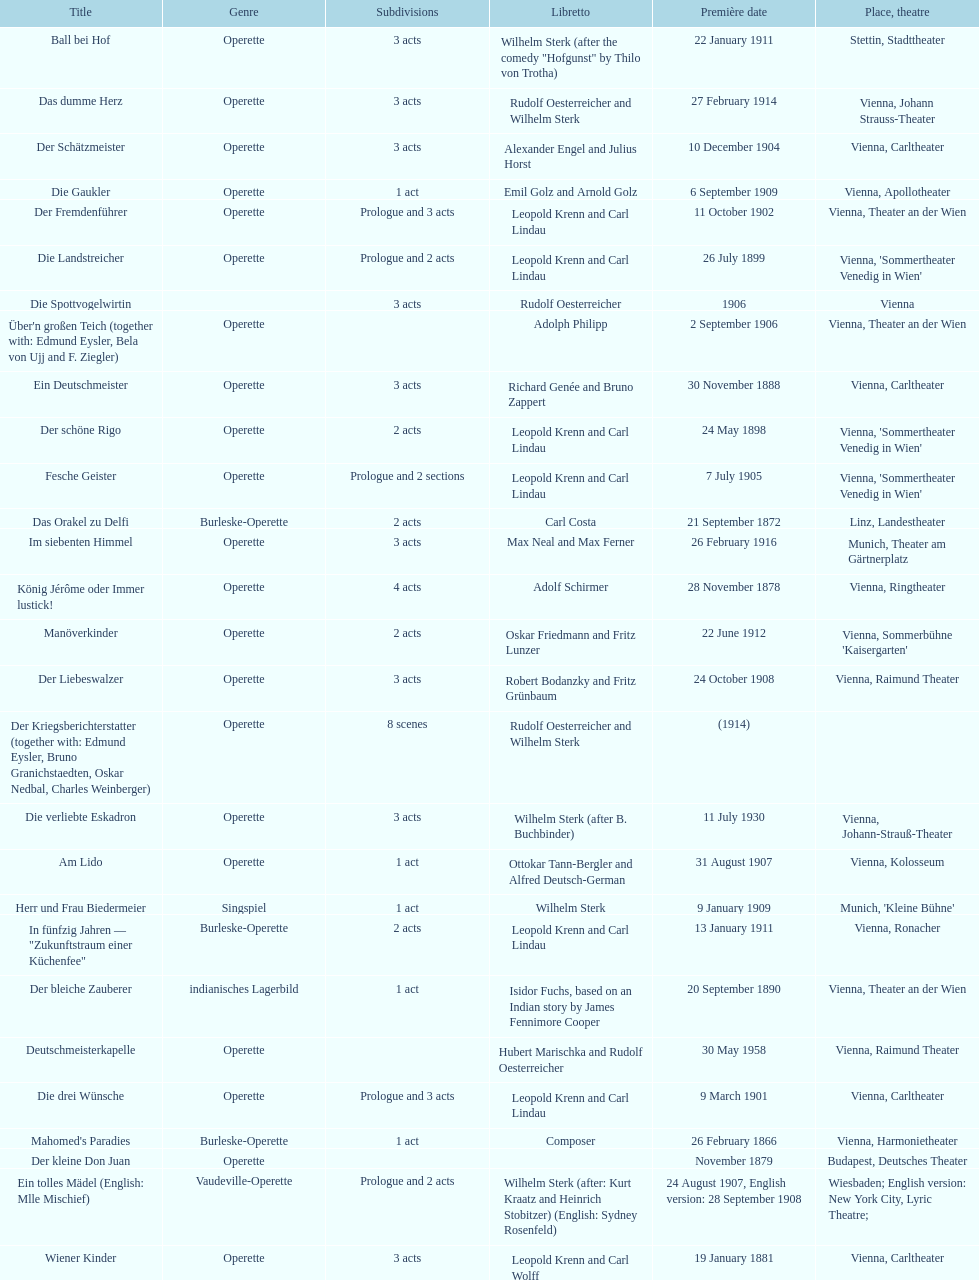Does der liebeswalzer or manöverkinder contain more acts? Der Liebeswalzer. 